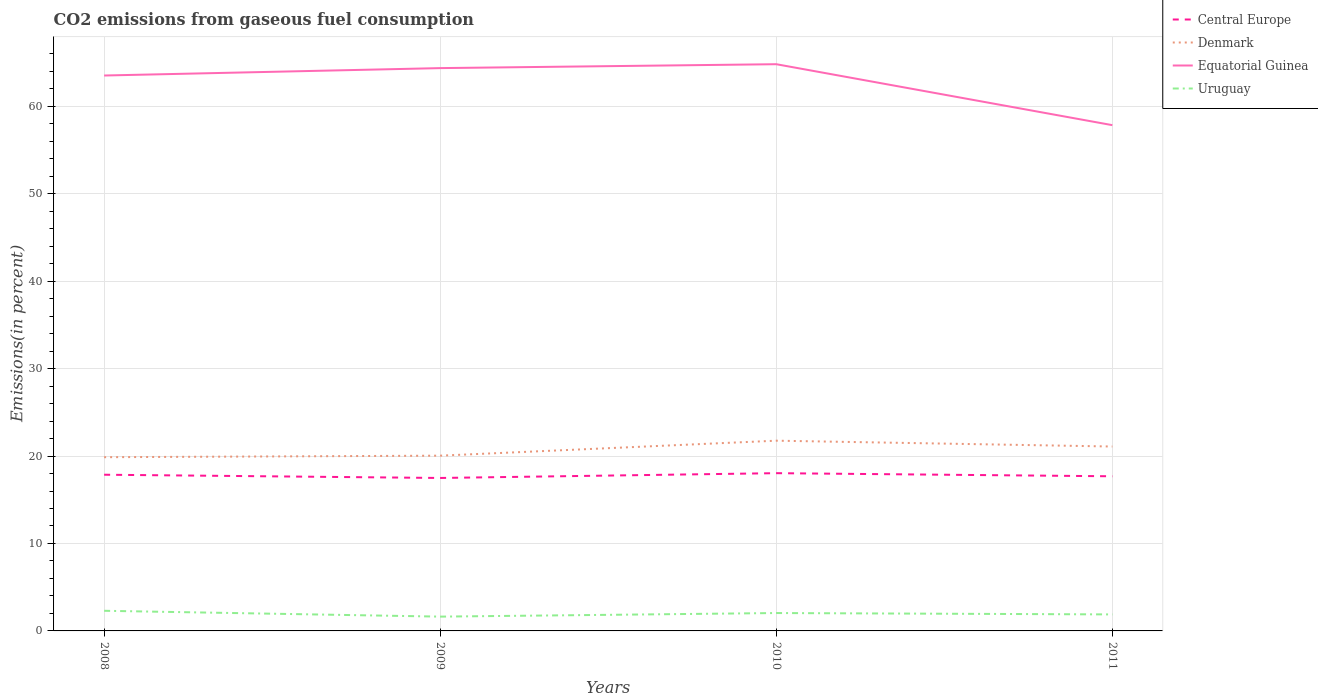Across all years, what is the maximum total CO2 emitted in Equatorial Guinea?
Ensure brevity in your answer.  57.84. In which year was the total CO2 emitted in Denmark maximum?
Provide a short and direct response. 2008. What is the total total CO2 emitted in Central Europe in the graph?
Provide a succinct answer. -0.18. What is the difference between the highest and the second highest total CO2 emitted in Central Europe?
Offer a terse response. 0.55. What is the difference between the highest and the lowest total CO2 emitted in Uruguay?
Ensure brevity in your answer.  2. Is the total CO2 emitted in Central Europe strictly greater than the total CO2 emitted in Equatorial Guinea over the years?
Provide a short and direct response. Yes. What is the difference between two consecutive major ticks on the Y-axis?
Offer a terse response. 10. Does the graph contain grids?
Offer a very short reply. Yes. Where does the legend appear in the graph?
Offer a very short reply. Top right. How many legend labels are there?
Keep it short and to the point. 4. What is the title of the graph?
Offer a very short reply. CO2 emissions from gaseous fuel consumption. What is the label or title of the Y-axis?
Make the answer very short. Emissions(in percent). What is the Emissions(in percent) of Central Europe in 2008?
Give a very brief answer. 17.86. What is the Emissions(in percent) in Denmark in 2008?
Make the answer very short. 19.87. What is the Emissions(in percent) of Equatorial Guinea in 2008?
Give a very brief answer. 63.52. What is the Emissions(in percent) of Uruguay in 2008?
Your answer should be compact. 2.3. What is the Emissions(in percent) in Central Europe in 2009?
Make the answer very short. 17.49. What is the Emissions(in percent) of Denmark in 2009?
Offer a very short reply. 20.04. What is the Emissions(in percent) in Equatorial Guinea in 2009?
Ensure brevity in your answer.  64.37. What is the Emissions(in percent) in Uruguay in 2009?
Keep it short and to the point. 1.63. What is the Emissions(in percent) in Central Europe in 2010?
Keep it short and to the point. 18.04. What is the Emissions(in percent) of Denmark in 2010?
Your answer should be very brief. 21.76. What is the Emissions(in percent) in Equatorial Guinea in 2010?
Offer a very short reply. 64.81. What is the Emissions(in percent) of Uruguay in 2010?
Your answer should be compact. 2.05. What is the Emissions(in percent) in Central Europe in 2011?
Your answer should be very brief. 17.68. What is the Emissions(in percent) in Denmark in 2011?
Your answer should be compact. 21.09. What is the Emissions(in percent) in Equatorial Guinea in 2011?
Keep it short and to the point. 57.84. What is the Emissions(in percent) in Uruguay in 2011?
Keep it short and to the point. 1.89. Across all years, what is the maximum Emissions(in percent) in Central Europe?
Your answer should be very brief. 18.04. Across all years, what is the maximum Emissions(in percent) of Denmark?
Make the answer very short. 21.76. Across all years, what is the maximum Emissions(in percent) in Equatorial Guinea?
Keep it short and to the point. 64.81. Across all years, what is the maximum Emissions(in percent) of Uruguay?
Give a very brief answer. 2.3. Across all years, what is the minimum Emissions(in percent) in Central Europe?
Give a very brief answer. 17.49. Across all years, what is the minimum Emissions(in percent) of Denmark?
Your response must be concise. 19.87. Across all years, what is the minimum Emissions(in percent) of Equatorial Guinea?
Make the answer very short. 57.84. Across all years, what is the minimum Emissions(in percent) of Uruguay?
Your answer should be very brief. 1.63. What is the total Emissions(in percent) in Central Europe in the graph?
Your answer should be compact. 71.08. What is the total Emissions(in percent) of Denmark in the graph?
Make the answer very short. 82.75. What is the total Emissions(in percent) of Equatorial Guinea in the graph?
Provide a succinct answer. 250.53. What is the total Emissions(in percent) of Uruguay in the graph?
Your answer should be compact. 7.87. What is the difference between the Emissions(in percent) of Central Europe in 2008 and that in 2009?
Give a very brief answer. 0.37. What is the difference between the Emissions(in percent) of Denmark in 2008 and that in 2009?
Offer a terse response. -0.18. What is the difference between the Emissions(in percent) of Equatorial Guinea in 2008 and that in 2009?
Offer a very short reply. -0.85. What is the difference between the Emissions(in percent) in Uruguay in 2008 and that in 2009?
Your answer should be very brief. 0.67. What is the difference between the Emissions(in percent) in Central Europe in 2008 and that in 2010?
Provide a succinct answer. -0.18. What is the difference between the Emissions(in percent) of Denmark in 2008 and that in 2010?
Your answer should be very brief. -1.89. What is the difference between the Emissions(in percent) in Equatorial Guinea in 2008 and that in 2010?
Provide a short and direct response. -1.29. What is the difference between the Emissions(in percent) of Uruguay in 2008 and that in 2010?
Give a very brief answer. 0.26. What is the difference between the Emissions(in percent) of Central Europe in 2008 and that in 2011?
Offer a very short reply. 0.18. What is the difference between the Emissions(in percent) of Denmark in 2008 and that in 2011?
Make the answer very short. -1.22. What is the difference between the Emissions(in percent) of Equatorial Guinea in 2008 and that in 2011?
Ensure brevity in your answer.  5.68. What is the difference between the Emissions(in percent) in Uruguay in 2008 and that in 2011?
Make the answer very short. 0.42. What is the difference between the Emissions(in percent) of Central Europe in 2009 and that in 2010?
Your response must be concise. -0.55. What is the difference between the Emissions(in percent) in Denmark in 2009 and that in 2010?
Offer a terse response. -1.71. What is the difference between the Emissions(in percent) of Equatorial Guinea in 2009 and that in 2010?
Your answer should be very brief. -0.45. What is the difference between the Emissions(in percent) of Uruguay in 2009 and that in 2010?
Your answer should be very brief. -0.41. What is the difference between the Emissions(in percent) of Central Europe in 2009 and that in 2011?
Offer a very short reply. -0.19. What is the difference between the Emissions(in percent) in Denmark in 2009 and that in 2011?
Offer a terse response. -1.05. What is the difference between the Emissions(in percent) in Equatorial Guinea in 2009 and that in 2011?
Your answer should be very brief. 6.53. What is the difference between the Emissions(in percent) in Uruguay in 2009 and that in 2011?
Your response must be concise. -0.25. What is the difference between the Emissions(in percent) of Central Europe in 2010 and that in 2011?
Give a very brief answer. 0.36. What is the difference between the Emissions(in percent) in Denmark in 2010 and that in 2011?
Your answer should be very brief. 0.67. What is the difference between the Emissions(in percent) of Equatorial Guinea in 2010 and that in 2011?
Offer a terse response. 6.97. What is the difference between the Emissions(in percent) of Uruguay in 2010 and that in 2011?
Offer a terse response. 0.16. What is the difference between the Emissions(in percent) in Central Europe in 2008 and the Emissions(in percent) in Denmark in 2009?
Your response must be concise. -2.18. What is the difference between the Emissions(in percent) in Central Europe in 2008 and the Emissions(in percent) in Equatorial Guinea in 2009?
Your answer should be very brief. -46.5. What is the difference between the Emissions(in percent) in Central Europe in 2008 and the Emissions(in percent) in Uruguay in 2009?
Offer a terse response. 16.23. What is the difference between the Emissions(in percent) in Denmark in 2008 and the Emissions(in percent) in Equatorial Guinea in 2009?
Offer a terse response. -44.5. What is the difference between the Emissions(in percent) of Denmark in 2008 and the Emissions(in percent) of Uruguay in 2009?
Your answer should be compact. 18.23. What is the difference between the Emissions(in percent) of Equatorial Guinea in 2008 and the Emissions(in percent) of Uruguay in 2009?
Your answer should be very brief. 61.88. What is the difference between the Emissions(in percent) in Central Europe in 2008 and the Emissions(in percent) in Denmark in 2010?
Offer a very short reply. -3.89. What is the difference between the Emissions(in percent) in Central Europe in 2008 and the Emissions(in percent) in Equatorial Guinea in 2010?
Your response must be concise. -46.95. What is the difference between the Emissions(in percent) of Central Europe in 2008 and the Emissions(in percent) of Uruguay in 2010?
Your answer should be compact. 15.82. What is the difference between the Emissions(in percent) of Denmark in 2008 and the Emissions(in percent) of Equatorial Guinea in 2010?
Offer a very short reply. -44.94. What is the difference between the Emissions(in percent) of Denmark in 2008 and the Emissions(in percent) of Uruguay in 2010?
Give a very brief answer. 17.82. What is the difference between the Emissions(in percent) in Equatorial Guinea in 2008 and the Emissions(in percent) in Uruguay in 2010?
Your response must be concise. 61.47. What is the difference between the Emissions(in percent) in Central Europe in 2008 and the Emissions(in percent) in Denmark in 2011?
Your response must be concise. -3.22. What is the difference between the Emissions(in percent) of Central Europe in 2008 and the Emissions(in percent) of Equatorial Guinea in 2011?
Make the answer very short. -39.98. What is the difference between the Emissions(in percent) in Central Europe in 2008 and the Emissions(in percent) in Uruguay in 2011?
Your response must be concise. 15.98. What is the difference between the Emissions(in percent) of Denmark in 2008 and the Emissions(in percent) of Equatorial Guinea in 2011?
Give a very brief answer. -37.97. What is the difference between the Emissions(in percent) in Denmark in 2008 and the Emissions(in percent) in Uruguay in 2011?
Ensure brevity in your answer.  17.98. What is the difference between the Emissions(in percent) in Equatorial Guinea in 2008 and the Emissions(in percent) in Uruguay in 2011?
Offer a very short reply. 61.63. What is the difference between the Emissions(in percent) in Central Europe in 2009 and the Emissions(in percent) in Denmark in 2010?
Provide a short and direct response. -4.26. What is the difference between the Emissions(in percent) of Central Europe in 2009 and the Emissions(in percent) of Equatorial Guinea in 2010?
Make the answer very short. -47.32. What is the difference between the Emissions(in percent) in Central Europe in 2009 and the Emissions(in percent) in Uruguay in 2010?
Provide a short and direct response. 15.45. What is the difference between the Emissions(in percent) in Denmark in 2009 and the Emissions(in percent) in Equatorial Guinea in 2010?
Your response must be concise. -44.77. What is the difference between the Emissions(in percent) of Denmark in 2009 and the Emissions(in percent) of Uruguay in 2010?
Your answer should be very brief. 18. What is the difference between the Emissions(in percent) of Equatorial Guinea in 2009 and the Emissions(in percent) of Uruguay in 2010?
Give a very brief answer. 62.32. What is the difference between the Emissions(in percent) in Central Europe in 2009 and the Emissions(in percent) in Denmark in 2011?
Provide a succinct answer. -3.6. What is the difference between the Emissions(in percent) in Central Europe in 2009 and the Emissions(in percent) in Equatorial Guinea in 2011?
Provide a short and direct response. -40.35. What is the difference between the Emissions(in percent) in Central Europe in 2009 and the Emissions(in percent) in Uruguay in 2011?
Keep it short and to the point. 15.6. What is the difference between the Emissions(in percent) of Denmark in 2009 and the Emissions(in percent) of Equatorial Guinea in 2011?
Your answer should be very brief. -37.8. What is the difference between the Emissions(in percent) of Denmark in 2009 and the Emissions(in percent) of Uruguay in 2011?
Provide a short and direct response. 18.16. What is the difference between the Emissions(in percent) of Equatorial Guinea in 2009 and the Emissions(in percent) of Uruguay in 2011?
Give a very brief answer. 62.48. What is the difference between the Emissions(in percent) of Central Europe in 2010 and the Emissions(in percent) of Denmark in 2011?
Ensure brevity in your answer.  -3.05. What is the difference between the Emissions(in percent) of Central Europe in 2010 and the Emissions(in percent) of Equatorial Guinea in 2011?
Offer a terse response. -39.8. What is the difference between the Emissions(in percent) in Central Europe in 2010 and the Emissions(in percent) in Uruguay in 2011?
Your answer should be very brief. 16.15. What is the difference between the Emissions(in percent) in Denmark in 2010 and the Emissions(in percent) in Equatorial Guinea in 2011?
Provide a short and direct response. -36.08. What is the difference between the Emissions(in percent) in Denmark in 2010 and the Emissions(in percent) in Uruguay in 2011?
Your response must be concise. 19.87. What is the difference between the Emissions(in percent) in Equatorial Guinea in 2010 and the Emissions(in percent) in Uruguay in 2011?
Give a very brief answer. 62.93. What is the average Emissions(in percent) in Central Europe per year?
Offer a terse response. 17.77. What is the average Emissions(in percent) of Denmark per year?
Provide a short and direct response. 20.69. What is the average Emissions(in percent) of Equatorial Guinea per year?
Keep it short and to the point. 62.63. What is the average Emissions(in percent) of Uruguay per year?
Make the answer very short. 1.97. In the year 2008, what is the difference between the Emissions(in percent) in Central Europe and Emissions(in percent) in Denmark?
Your answer should be very brief. -2. In the year 2008, what is the difference between the Emissions(in percent) in Central Europe and Emissions(in percent) in Equatorial Guinea?
Your answer should be very brief. -45.65. In the year 2008, what is the difference between the Emissions(in percent) in Central Europe and Emissions(in percent) in Uruguay?
Your answer should be very brief. 15.56. In the year 2008, what is the difference between the Emissions(in percent) of Denmark and Emissions(in percent) of Equatorial Guinea?
Provide a succinct answer. -43.65. In the year 2008, what is the difference between the Emissions(in percent) in Denmark and Emissions(in percent) in Uruguay?
Your answer should be compact. 17.56. In the year 2008, what is the difference between the Emissions(in percent) of Equatorial Guinea and Emissions(in percent) of Uruguay?
Your answer should be very brief. 61.22. In the year 2009, what is the difference between the Emissions(in percent) in Central Europe and Emissions(in percent) in Denmark?
Give a very brief answer. -2.55. In the year 2009, what is the difference between the Emissions(in percent) in Central Europe and Emissions(in percent) in Equatorial Guinea?
Give a very brief answer. -46.87. In the year 2009, what is the difference between the Emissions(in percent) in Central Europe and Emissions(in percent) in Uruguay?
Offer a terse response. 15.86. In the year 2009, what is the difference between the Emissions(in percent) of Denmark and Emissions(in percent) of Equatorial Guinea?
Offer a very short reply. -44.32. In the year 2009, what is the difference between the Emissions(in percent) of Denmark and Emissions(in percent) of Uruguay?
Keep it short and to the point. 18.41. In the year 2009, what is the difference between the Emissions(in percent) in Equatorial Guinea and Emissions(in percent) in Uruguay?
Make the answer very short. 62.73. In the year 2010, what is the difference between the Emissions(in percent) of Central Europe and Emissions(in percent) of Denmark?
Keep it short and to the point. -3.71. In the year 2010, what is the difference between the Emissions(in percent) of Central Europe and Emissions(in percent) of Equatorial Guinea?
Make the answer very short. -46.77. In the year 2010, what is the difference between the Emissions(in percent) of Central Europe and Emissions(in percent) of Uruguay?
Provide a succinct answer. 16. In the year 2010, what is the difference between the Emissions(in percent) of Denmark and Emissions(in percent) of Equatorial Guinea?
Keep it short and to the point. -43.06. In the year 2010, what is the difference between the Emissions(in percent) of Denmark and Emissions(in percent) of Uruguay?
Provide a succinct answer. 19.71. In the year 2010, what is the difference between the Emissions(in percent) of Equatorial Guinea and Emissions(in percent) of Uruguay?
Offer a very short reply. 62.77. In the year 2011, what is the difference between the Emissions(in percent) of Central Europe and Emissions(in percent) of Denmark?
Provide a short and direct response. -3.4. In the year 2011, what is the difference between the Emissions(in percent) of Central Europe and Emissions(in percent) of Equatorial Guinea?
Keep it short and to the point. -40.16. In the year 2011, what is the difference between the Emissions(in percent) in Central Europe and Emissions(in percent) in Uruguay?
Provide a succinct answer. 15.8. In the year 2011, what is the difference between the Emissions(in percent) of Denmark and Emissions(in percent) of Equatorial Guinea?
Your answer should be very brief. -36.75. In the year 2011, what is the difference between the Emissions(in percent) in Denmark and Emissions(in percent) in Uruguay?
Provide a short and direct response. 19.2. In the year 2011, what is the difference between the Emissions(in percent) of Equatorial Guinea and Emissions(in percent) of Uruguay?
Provide a succinct answer. 55.95. What is the ratio of the Emissions(in percent) of Central Europe in 2008 to that in 2009?
Provide a succinct answer. 1.02. What is the ratio of the Emissions(in percent) in Equatorial Guinea in 2008 to that in 2009?
Your answer should be compact. 0.99. What is the ratio of the Emissions(in percent) in Uruguay in 2008 to that in 2009?
Offer a very short reply. 1.41. What is the ratio of the Emissions(in percent) in Central Europe in 2008 to that in 2010?
Your answer should be very brief. 0.99. What is the ratio of the Emissions(in percent) of Denmark in 2008 to that in 2010?
Your response must be concise. 0.91. What is the ratio of the Emissions(in percent) of Equatorial Guinea in 2008 to that in 2010?
Ensure brevity in your answer.  0.98. What is the ratio of the Emissions(in percent) of Uruguay in 2008 to that in 2010?
Offer a terse response. 1.13. What is the ratio of the Emissions(in percent) in Central Europe in 2008 to that in 2011?
Your response must be concise. 1.01. What is the ratio of the Emissions(in percent) of Denmark in 2008 to that in 2011?
Your response must be concise. 0.94. What is the ratio of the Emissions(in percent) in Equatorial Guinea in 2008 to that in 2011?
Provide a short and direct response. 1.1. What is the ratio of the Emissions(in percent) of Uruguay in 2008 to that in 2011?
Your answer should be very brief. 1.22. What is the ratio of the Emissions(in percent) in Central Europe in 2009 to that in 2010?
Give a very brief answer. 0.97. What is the ratio of the Emissions(in percent) in Denmark in 2009 to that in 2010?
Offer a very short reply. 0.92. What is the ratio of the Emissions(in percent) in Equatorial Guinea in 2009 to that in 2010?
Keep it short and to the point. 0.99. What is the ratio of the Emissions(in percent) of Uruguay in 2009 to that in 2010?
Your response must be concise. 0.8. What is the ratio of the Emissions(in percent) in Denmark in 2009 to that in 2011?
Keep it short and to the point. 0.95. What is the ratio of the Emissions(in percent) of Equatorial Guinea in 2009 to that in 2011?
Make the answer very short. 1.11. What is the ratio of the Emissions(in percent) of Uruguay in 2009 to that in 2011?
Make the answer very short. 0.87. What is the ratio of the Emissions(in percent) in Central Europe in 2010 to that in 2011?
Give a very brief answer. 1.02. What is the ratio of the Emissions(in percent) in Denmark in 2010 to that in 2011?
Offer a terse response. 1.03. What is the ratio of the Emissions(in percent) of Equatorial Guinea in 2010 to that in 2011?
Offer a very short reply. 1.12. What is the ratio of the Emissions(in percent) in Uruguay in 2010 to that in 2011?
Provide a succinct answer. 1.08. What is the difference between the highest and the second highest Emissions(in percent) of Central Europe?
Make the answer very short. 0.18. What is the difference between the highest and the second highest Emissions(in percent) in Denmark?
Provide a succinct answer. 0.67. What is the difference between the highest and the second highest Emissions(in percent) of Equatorial Guinea?
Ensure brevity in your answer.  0.45. What is the difference between the highest and the second highest Emissions(in percent) of Uruguay?
Your response must be concise. 0.26. What is the difference between the highest and the lowest Emissions(in percent) of Central Europe?
Offer a terse response. 0.55. What is the difference between the highest and the lowest Emissions(in percent) in Denmark?
Your response must be concise. 1.89. What is the difference between the highest and the lowest Emissions(in percent) of Equatorial Guinea?
Your response must be concise. 6.97. What is the difference between the highest and the lowest Emissions(in percent) in Uruguay?
Keep it short and to the point. 0.67. 